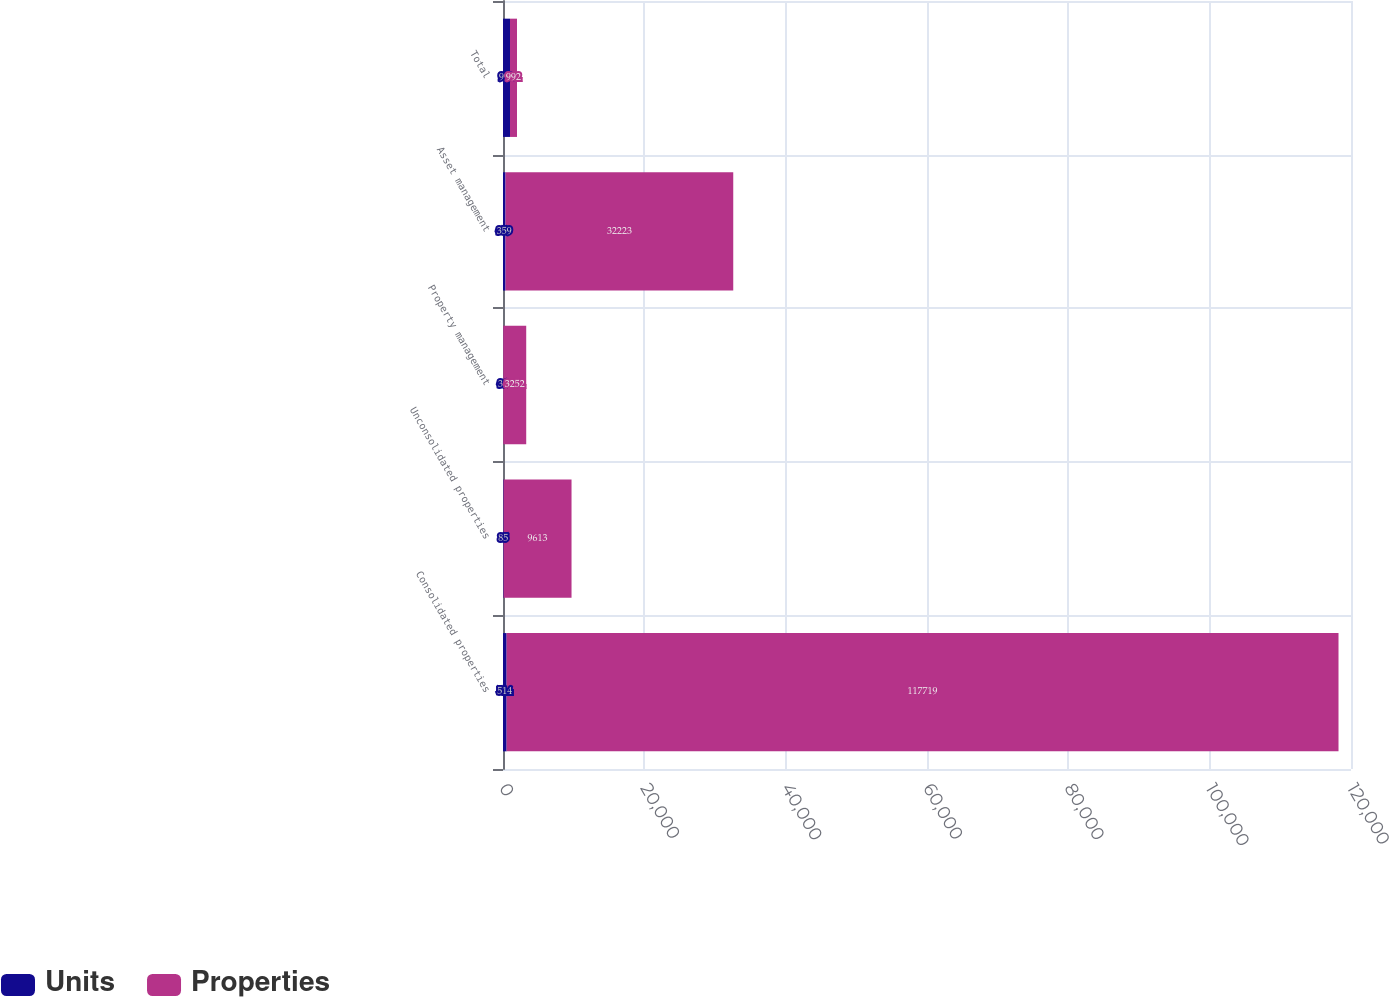Convert chart to OTSL. <chart><loc_0><loc_0><loc_500><loc_500><stacked_bar_chart><ecel><fcel>Consolidated properties<fcel>Unconsolidated properties<fcel>Property management<fcel>Asset management<fcel>Total<nl><fcel>Units<fcel>514<fcel>85<fcel>34<fcel>359<fcel>992<nl><fcel>Properties<fcel>117719<fcel>9613<fcel>3252<fcel>32223<fcel>992<nl></chart> 